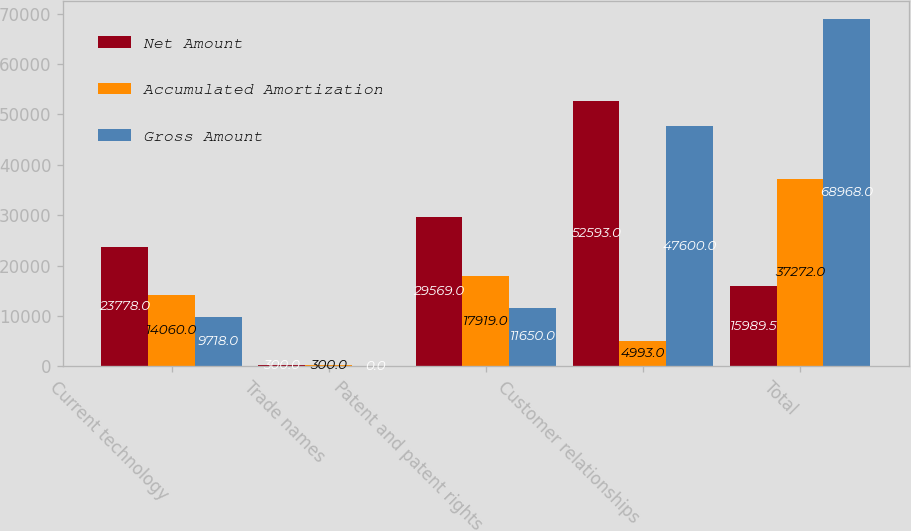Convert chart. <chart><loc_0><loc_0><loc_500><loc_500><stacked_bar_chart><ecel><fcel>Current technology<fcel>Trade names<fcel>Patent and patent rights<fcel>Customer relationships<fcel>Total<nl><fcel>Net Amount<fcel>23778<fcel>300<fcel>29569<fcel>52593<fcel>15989.5<nl><fcel>Accumulated Amortization<fcel>14060<fcel>300<fcel>17919<fcel>4993<fcel>37272<nl><fcel>Gross Amount<fcel>9718<fcel>0<fcel>11650<fcel>47600<fcel>68968<nl></chart> 